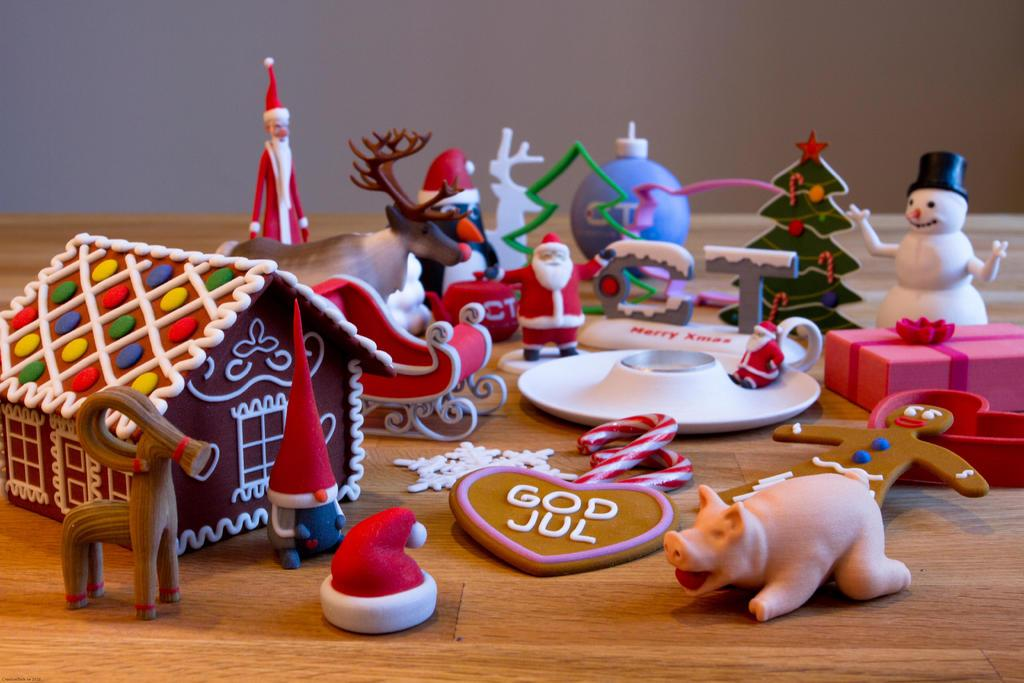What type of toy is present in the image? There is a toy house in the image. What animal is in the image? There is a pig in the image. What is the purpose of the plate in the image? The plate is likely used for holding or serving food or other items. What type of plant is visible in the image? There is a tree in the image. Where are the objects located in the image? The objects are on a table. What advice does the pig give to the toy house in the image? There is no interaction or dialogue between the pig and the toy house in the image, so it is not possible to determine any advice given. 